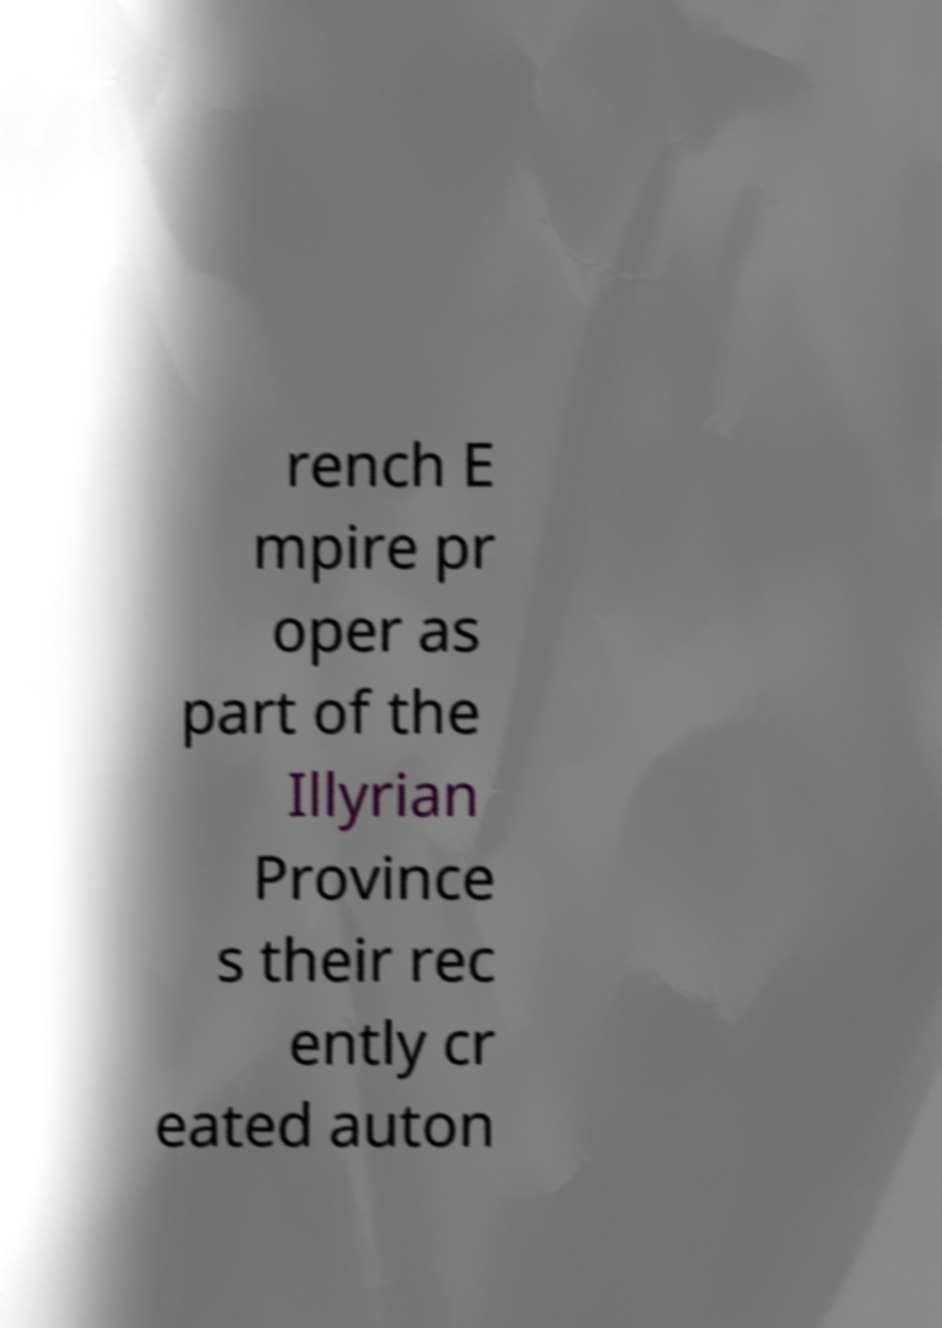Can you accurately transcribe the text from the provided image for me? rench E mpire pr oper as part of the Illyrian Province s their rec ently cr eated auton 